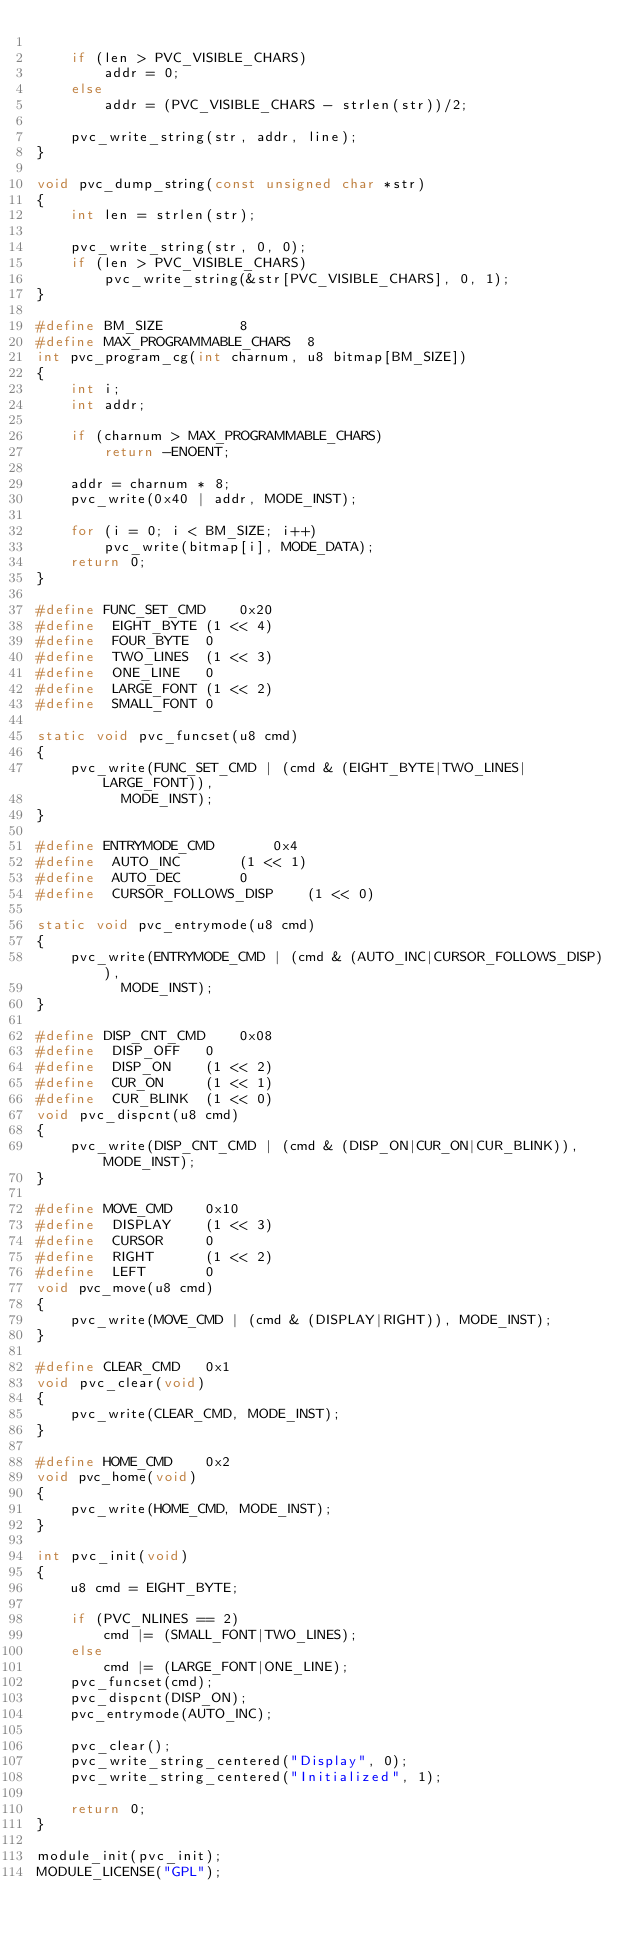<code> <loc_0><loc_0><loc_500><loc_500><_C_>
	if (len > PVC_VISIBLE_CHARS)
		addr = 0;
	else
		addr = (PVC_VISIBLE_CHARS - strlen(str))/2;

	pvc_write_string(str, addr, line);
}

void pvc_dump_string(const unsigned char *str)
{
	int len = strlen(str);

	pvc_write_string(str, 0, 0);
	if (len > PVC_VISIBLE_CHARS)
		pvc_write_string(&str[PVC_VISIBLE_CHARS], 0, 1);
}

#define BM_SIZE			8
#define MAX_PROGRAMMABLE_CHARS	8
int pvc_program_cg(int charnum, u8 bitmap[BM_SIZE])
{
	int i;
	int addr;

	if (charnum > MAX_PROGRAMMABLE_CHARS)
		return -ENOENT;

	addr = charnum * 8;
	pvc_write(0x40 | addr, MODE_INST);

	for (i = 0; i < BM_SIZE; i++)
		pvc_write(bitmap[i], MODE_DATA);
	return 0;
}

#define FUNC_SET_CMD	0x20
#define	 EIGHT_BYTE	(1 << 4)
#define	 FOUR_BYTE	0
#define	 TWO_LINES	(1 << 3)
#define	 ONE_LINE	0
#define	 LARGE_FONT	(1 << 2)
#define	 SMALL_FONT	0

static void pvc_funcset(u8 cmd)
{
	pvc_write(FUNC_SET_CMD | (cmd & (EIGHT_BYTE|TWO_LINES|LARGE_FONT)),
		  MODE_INST);
}

#define ENTRYMODE_CMD		0x4
#define	 AUTO_INC		(1 << 1)
#define	 AUTO_DEC		0
#define	 CURSOR_FOLLOWS_DISP	(1 << 0)

static void pvc_entrymode(u8 cmd)
{
	pvc_write(ENTRYMODE_CMD | (cmd & (AUTO_INC|CURSOR_FOLLOWS_DISP)),
		  MODE_INST);
}

#define DISP_CNT_CMD	0x08
#define	 DISP_OFF	0
#define	 DISP_ON	(1 << 2)
#define	 CUR_ON		(1 << 1)
#define	 CUR_BLINK	(1 << 0)
void pvc_dispcnt(u8 cmd)
{
	pvc_write(DISP_CNT_CMD | (cmd & (DISP_ON|CUR_ON|CUR_BLINK)), MODE_INST);
}

#define MOVE_CMD	0x10
#define	 DISPLAY	(1 << 3)
#define	 CURSOR		0
#define	 RIGHT		(1 << 2)
#define	 LEFT		0
void pvc_move(u8 cmd)
{
	pvc_write(MOVE_CMD | (cmd & (DISPLAY|RIGHT)), MODE_INST);
}

#define CLEAR_CMD	0x1
void pvc_clear(void)
{
	pvc_write(CLEAR_CMD, MODE_INST);
}

#define HOME_CMD	0x2
void pvc_home(void)
{
	pvc_write(HOME_CMD, MODE_INST);
}

int pvc_init(void)
{
	u8 cmd = EIGHT_BYTE;

	if (PVC_NLINES == 2)
		cmd |= (SMALL_FONT|TWO_LINES);
	else
		cmd |= (LARGE_FONT|ONE_LINE);
	pvc_funcset(cmd);
	pvc_dispcnt(DISP_ON);
	pvc_entrymode(AUTO_INC);

	pvc_clear();
	pvc_write_string_centered("Display", 0);
	pvc_write_string_centered("Initialized", 1);

	return 0;
}

module_init(pvc_init);
MODULE_LICENSE("GPL");
</code> 